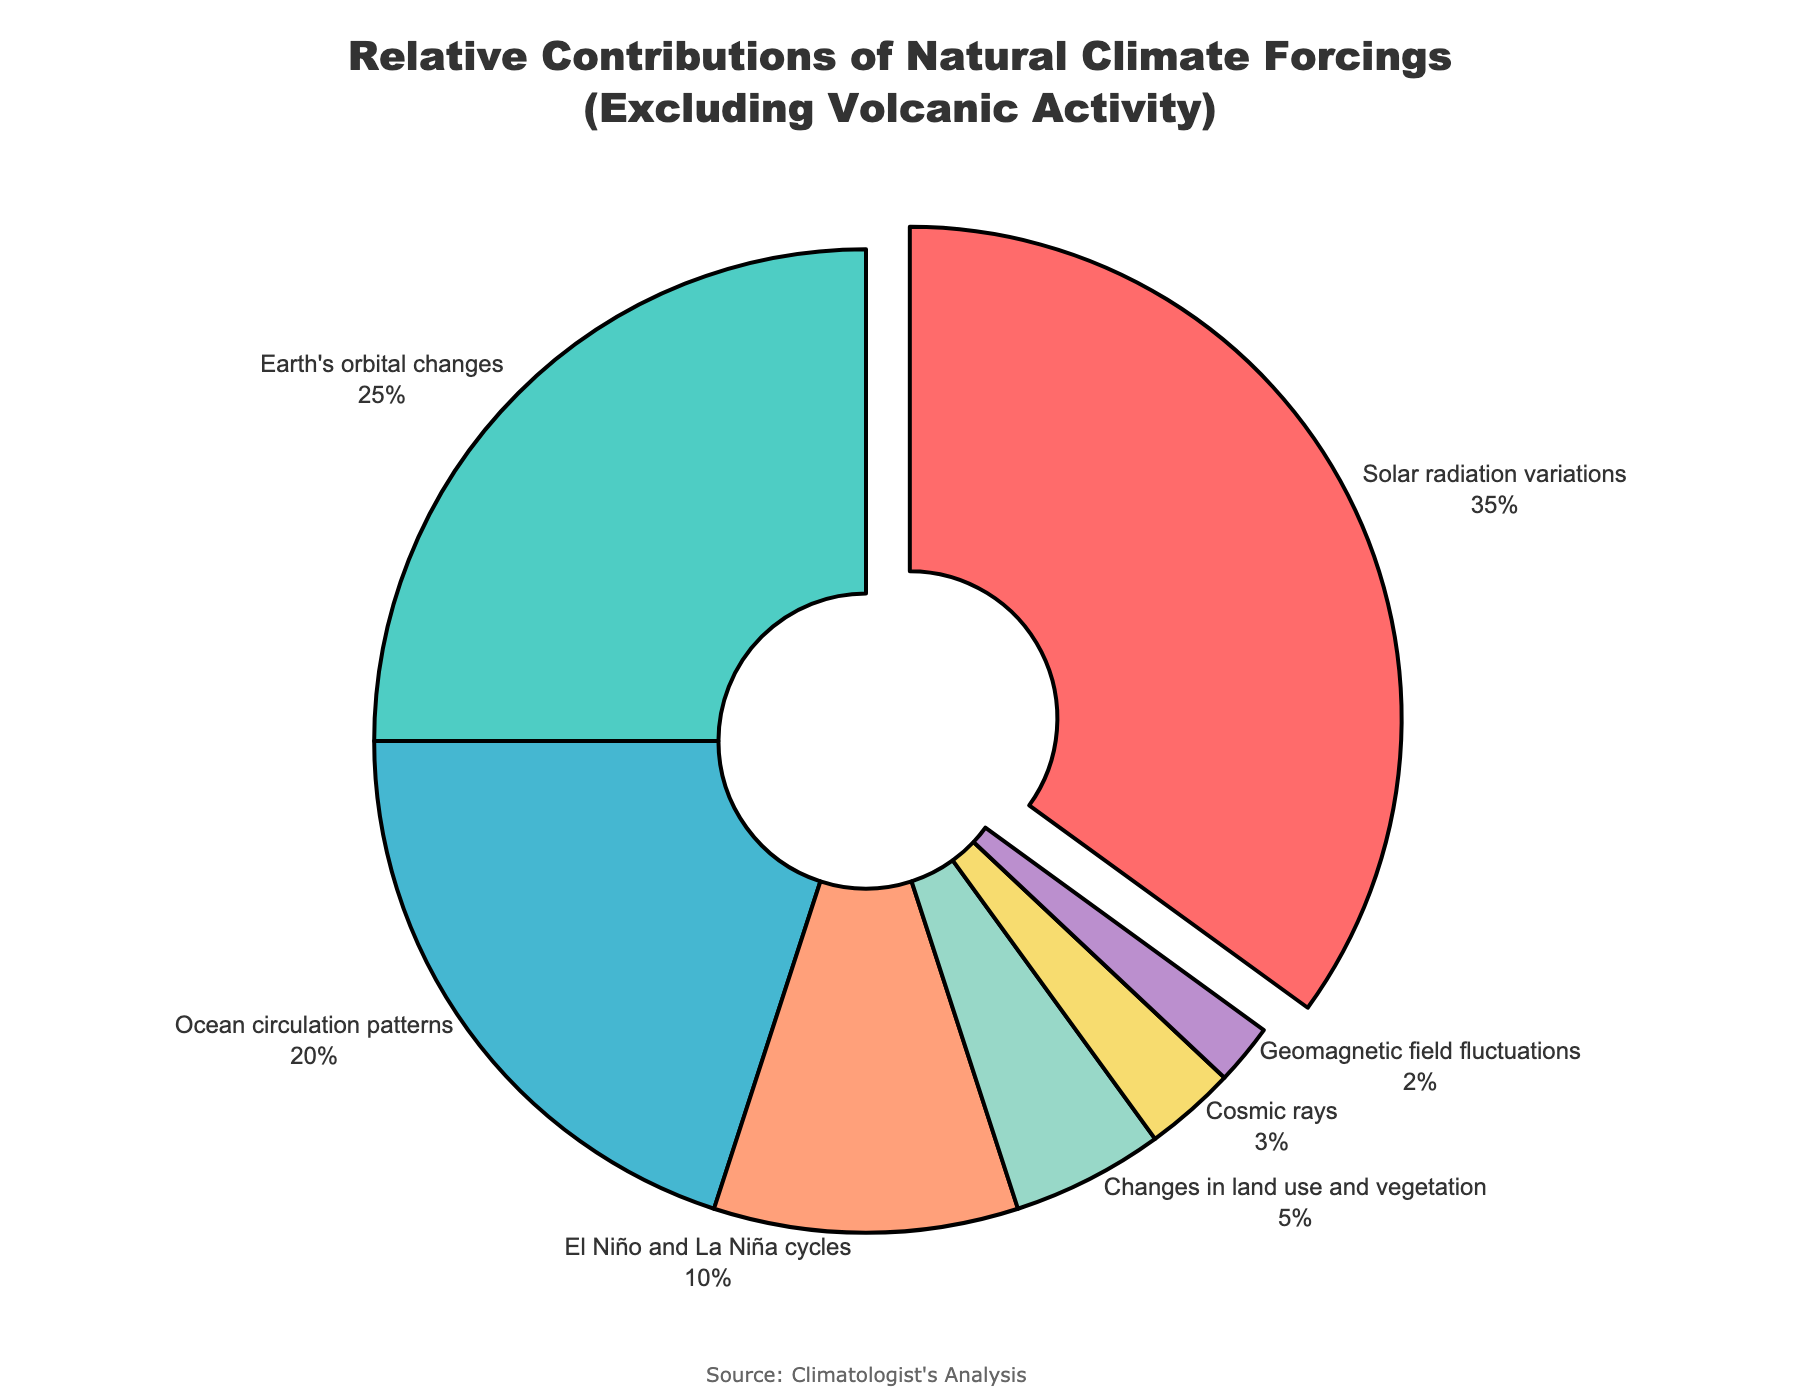Which category contributes the most to natural climate forcings excluding volcanic activity? Look at the category with the largest portion in the pie chart. The "Solar radiation variations" sector takes up the largest portion of the pie chart.
Answer: Solar radiation variations Which category contributes the least to natural climate forcings excluding volcanic activity? Identify the smallest portion in the pie chart. The "Geomagnetic field fluctuations" sector is the smallest.
Answer: Geomagnetic field fluctuations How much more does "Solar radiation variations" contribute compared to "El Niño and La Niña cycles"? Find the percentages for both categories: "Solar radiation variations" are 35%, and "El Niño and La Niña cycles" are 10%. Subtract the smaller percentage from the larger one: 35% - 10% = 25%.
Answer: 25% What is the combined contribution of "Earth's orbital changes" and "Ocean circulation patterns"? Add the percentages of both categories: "Earth's orbital changes" (25%) and "Ocean circulation patterns" (20%). 25% + 20% = 45%.
Answer: 45% Which categories contribute less than 10% each? Look at all segments with less than 10% contributions: "Changes in land use and vegetation" (5%), "Cosmic rays" (3%), and "Geomagnetic field fluctuations" (2%).
Answer: Changes in land use and vegetation, Cosmic rays, Geomagnetic field fluctuations What is the visual color used for "Ocean circulation patterns" and how does it help in differentiating it from other categories? Identify the color of the segment representing "Ocean circulation patterns". It's a light blue color, which is distinct from other colors used, helping differentiate it clearly.
Answer: Light blue What percentage of the total contributions is made up by the top two categories combined? Add the percentages of the top two categories: "Solar radiation variations" (35%) and "Earth's orbital changes" (25%). 35% + 25% = 60%.
Answer: 60% Which category is located directly to the right of "Earth's orbital changes" in the pie chart, based on the arrangement? Observe the pie chart's layout. The category directly to the right of "Earth's orbital changes" (green section) is "Ocean circulation patterns" (light blue section).
Answer: Ocean circulation patterns What is the average contribution of categories that contribute less than 20% each? Identify the categories with contributions less than 20%: "El Niño and La Niña cycles" (10%), "Changes in land use and vegetation" (5%), "Cosmic rays" (3%), and "Geomagnetic field fluctuations" (2%). Sum these percentages and divide by the number of categories: (10% + 5% + 3% + 2%) / 4 = 5%.
Answer: 5% 